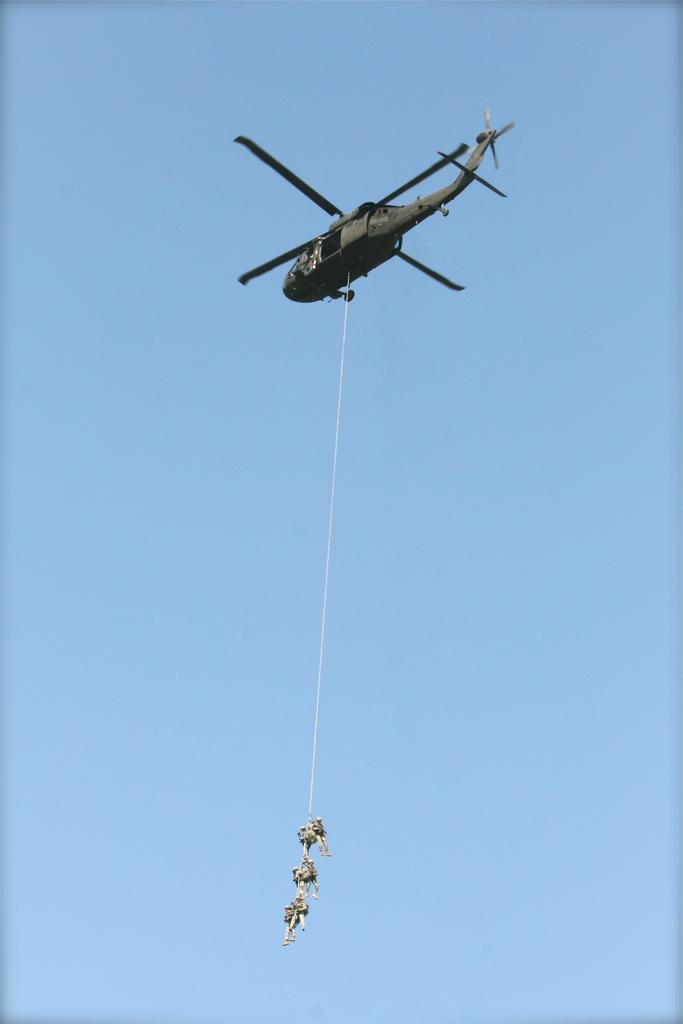What is the main subject of the image? The main subject of the image is a helicopter. What is attached to the helicopter? There is a rope attached to the helicopter. What are the people in the image doing? Three people are hanging on the rope. What can be seen in the background of the image? The sky is visible in the background of the image. What type of insurance policy do the people hanging on the rope have? There is no information about insurance policies in the image, as it focuses on the helicopter, rope, and people. --- Facts: 1. There is a car in the image. 2. The car is parked on the street. 3. There are trees on both sides of the street. 4. The sky is visible in the background of the image. Absurd Topics: parrot, piano, ocean Conversation: What is the main subject of the image? The main subject of the image is a car. Where is the car located in the image? The car is parked on the street. What can be seen on both sides of the street in the image? There are trees on both sides of the street. What is visible in the background of the image? The sky is visible in the background of the image. Reasoning: Let's think step by step in order to produce the conversation. We start by identifying the main subject of the image, which is the car. Next, we describe the location of the car, which is parked on the street. Then, we mention the trees on both sides of the street and the sky visible in the background. Absurd Question/Answer: Can you hear the parrot singing in the image? There is no parrot present in the image, so it cannot be heard singing. 